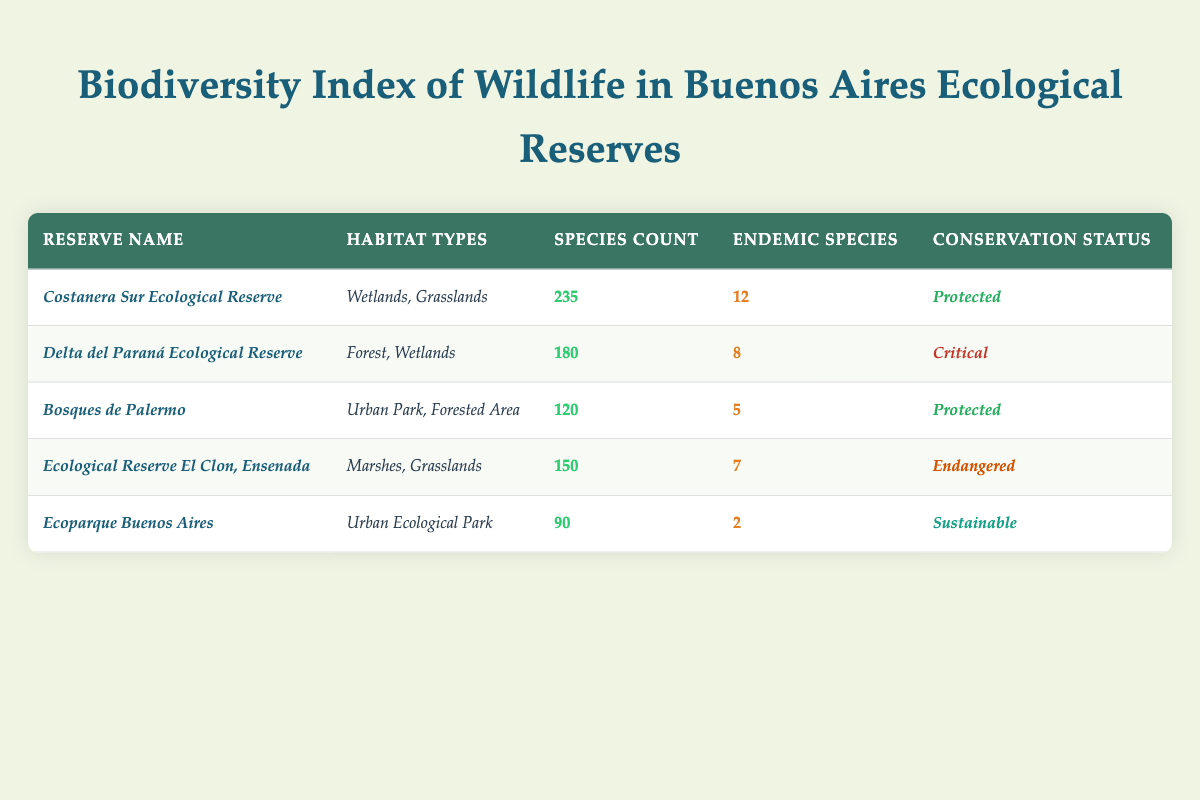What is the species count in the *Costanera Sur Ecological Reserve*? The table lists the species count for the *Costanera Sur Ecological Reserve* directly in its respective row, which shows a species count of 235.
Answer: 235 How many endemic species are found in the *Delta del Paraná Ecological Reserve*? In the row for the *Delta del Paraná Ecological Reserve*, the number of endemic species is noted as 8, which can be directly found in the table.
Answer: 8 Which ecological reserve has the highest conservation status? By examining the conservation status, the highest ranking is for the reserves with a status labeled as *Protected*. In the table, both *Costanera Sur Ecological Reserve* and *Bosques de Palermo* are marked as protected.
Answer: *Costanera Sur Ecological Reserve* and *Bosques de Palermo* What is the average number of endemic species across all reserves? To find the average, count the total number of reserves, which is 5, and sum the endemic species: (12 + 8 + 5 + 7 + 2) = 34. Then divide 34 by 5 for the average: 34 / 5 = 6.8.
Answer: 6.8 Which ecological reserve has the most species, and how many more species does it have than the one with the least? The *Costanera Sur Ecological Reserve* has the most species at 235, while *Ecoparque Buenos Aires* has the least with 90. The difference is calculated as 235 - 90 = 145.
Answer: *Costanera Sur Ecological Reserve*, 145 Is the conservation status of the *Ecological Reserve El Clon, Ensenada* considered *Critical*? The table specifically categorizes the *Ecological Reserve El Clon, Ensenada* as *Endangered*, not *Critical*. Therefore, the statement is false.
Answer: No If one were to categorize reserves into 'Protected' and 'Not Protected', how many belong to each category? The reserves labeled as *Protected* are *Costanera Sur Ecological Reserve* and *Bosques de Palermo* (2). The remaining three are categorized as *Critical*, *Endangered*, and *Sustainable* (3). Thus, we have 2 Protected and 3 Not Protected.
Answer: 2 Protected, 3 Not Protected What would the total species count be if we combine the species from *Ecoparque Buenos Aires* and *Bosques de Palermo*? The species count for *Ecoparque Buenos Aires* is 90 and for *Bosques de Palermo* it is 120. Adding these together gives: 90 + 120 = 210.
Answer: 210 Which ecological reserve has the least number of endemic species? The table shows that *Ecoparque Buenos Aires* has the least number of endemic species, which is 2.
Answer: *Ecoparque Buenos Aires* Which reserve has a conservation status of *Sustainable* and how many species does it have? According to the table, *Ecoparque Buenos Aires* has a conservation status of *Sustainable* and has 90 species.
Answer: *Ecoparque Buenos Aires*, 90 